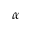<formula> <loc_0><loc_0><loc_500><loc_500>\alpha</formula> 